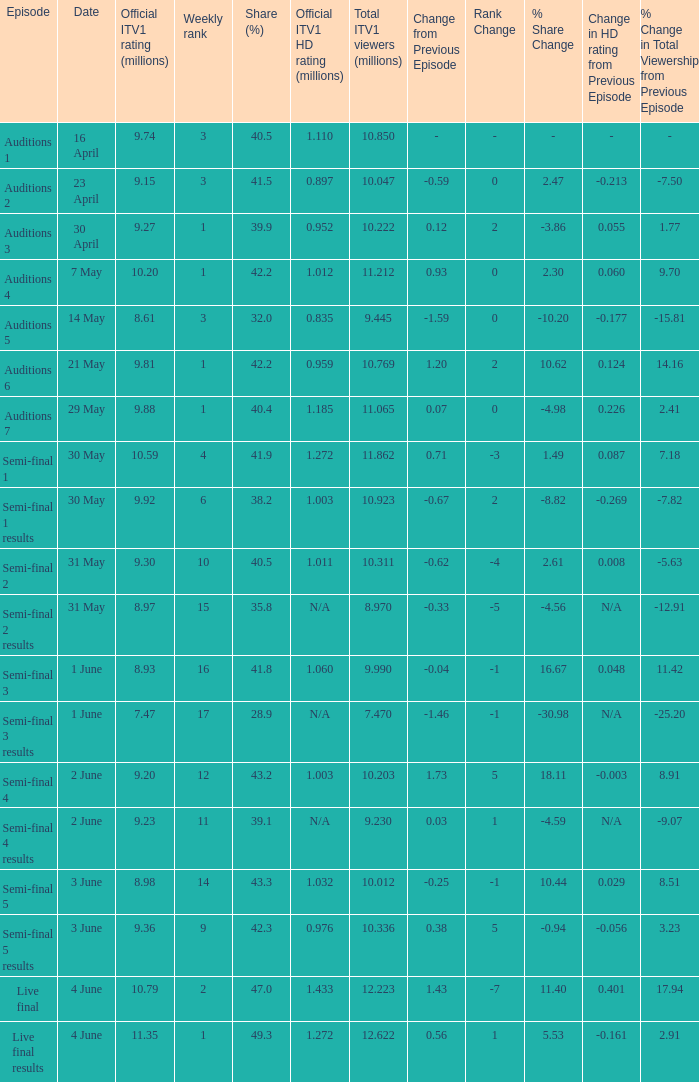Which episode had an official itv1 hd viewership of Auditions 7. 